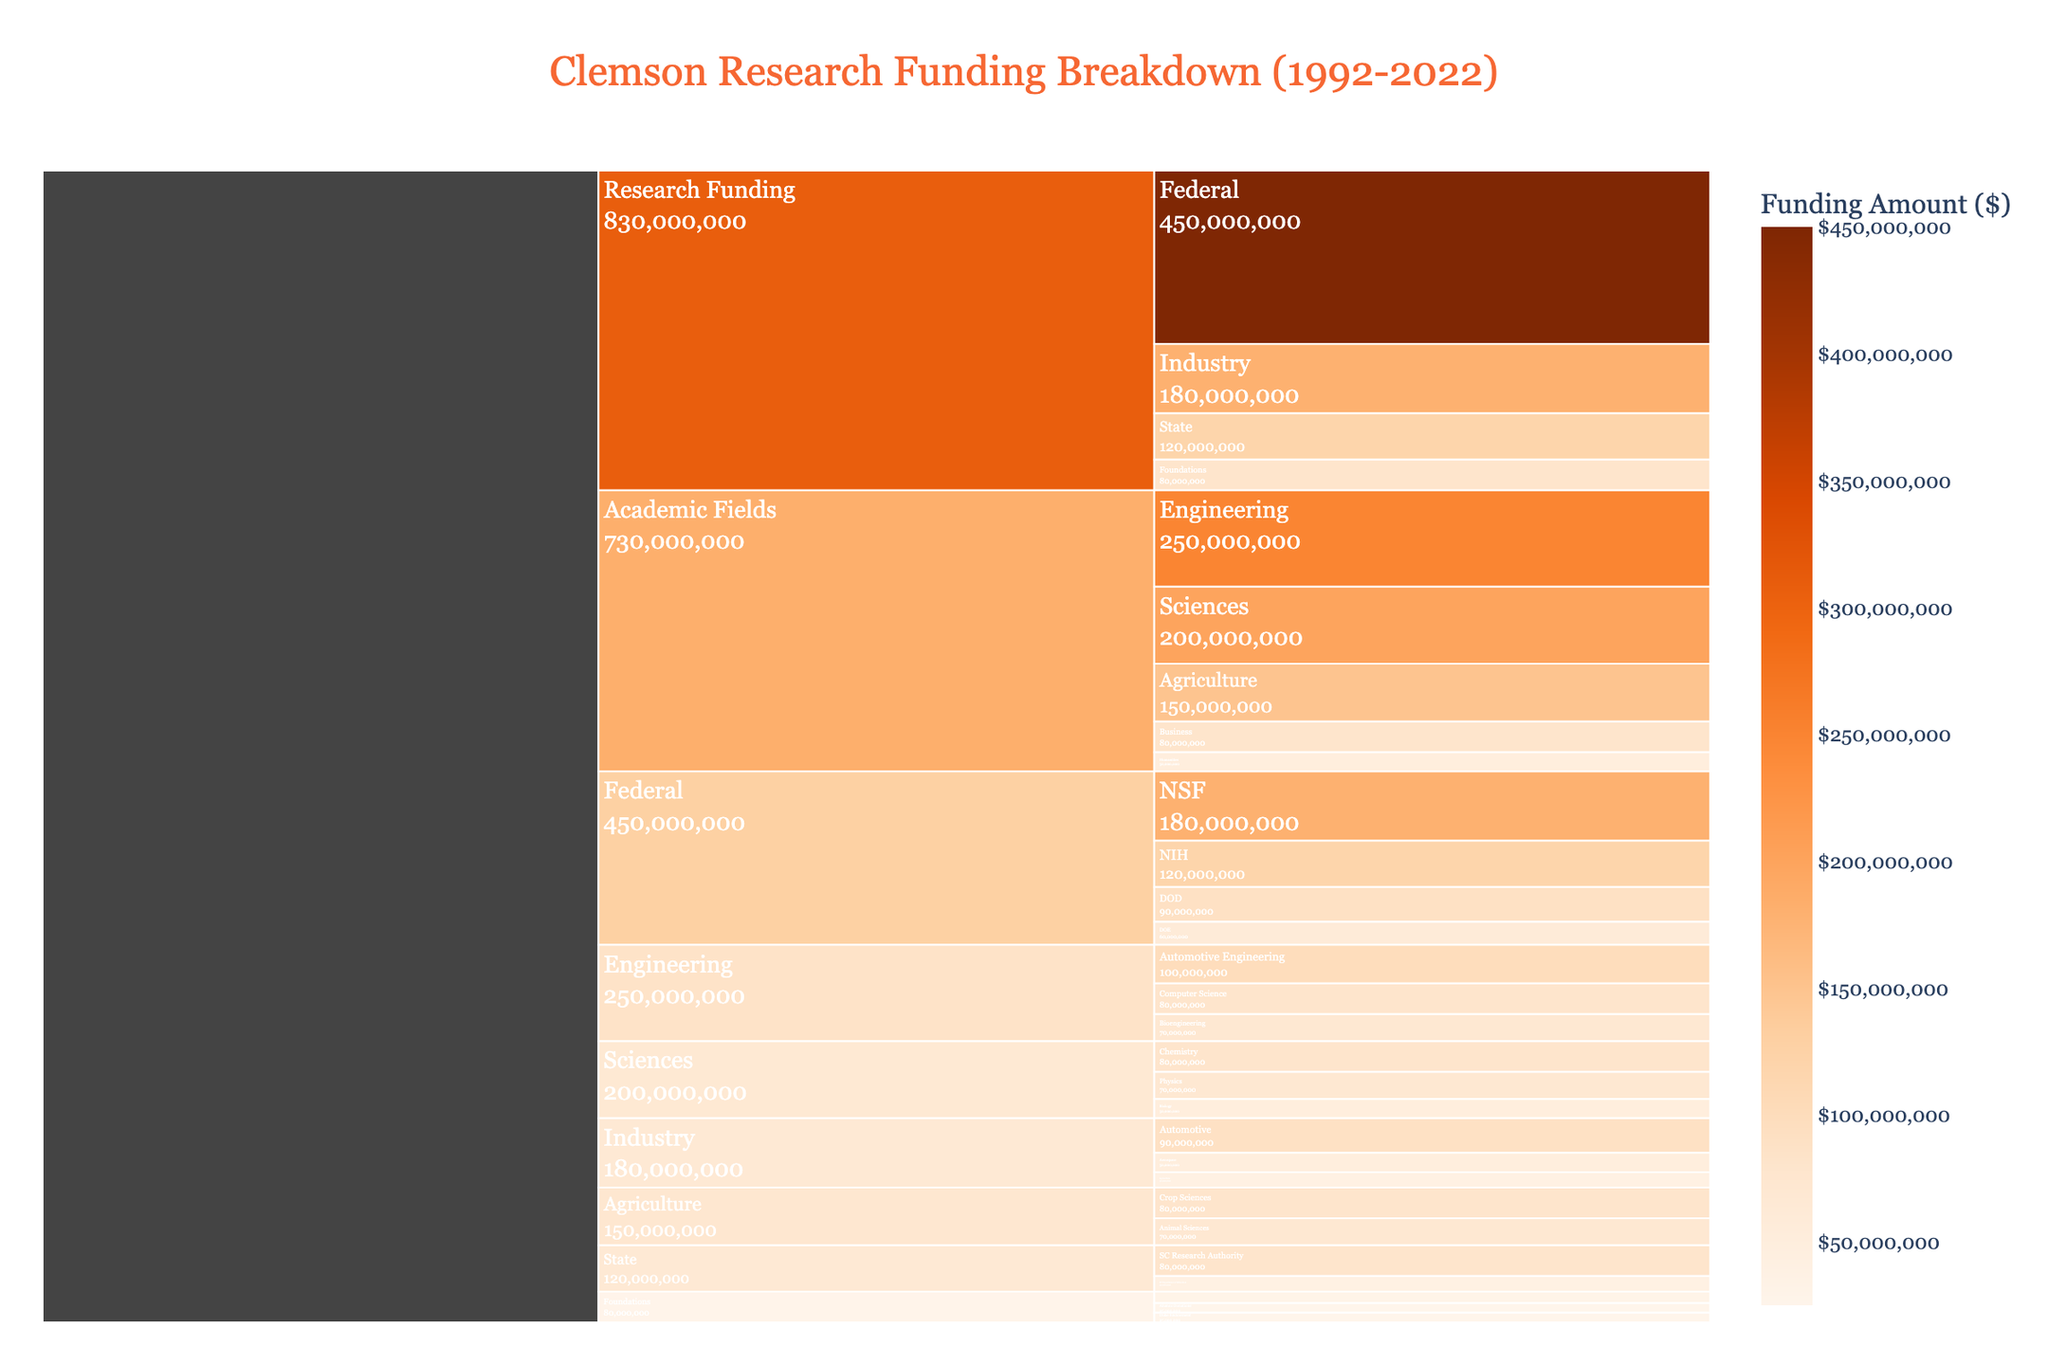What's the total amount of federal research funding for Clemson over the past 30 years? Add up the values of all subcategories under "Federal": NSF ($180,000,000), NIH ($120,000,000), DOD ($90,000,000), DOE ($60,000,000). Total = $180,000,000 + $120,000,000 + $90,000,000 + $60,000,000 = $450,000,000.
Answer: $450,000,000 What's the main source of research funding for Clemson? Look at the highest value among the main funding categories: Federal ($450,000,000), State ($120,000,000), Industry ($180,000,000), Foundations ($80,000,000).
Answer: Federal How much more funding does Engineering receive than Humanities? Subtract the value for Humanities from Engineering: $250,000,000 (Engineering) - $50,000,000 (Humanities) = $200,000,000.
Answer: $200,000,000 Which academic field gets the most research funding? Identify the category with the highest value under "Academic Fields": Engineering ($250,000,000), Sciences ($200,000,000), Agriculture ($150,000,000), Business ($80,000,000), Humanities ($50,000,000).
Answer: Engineering What's the total funding for academic fields related to Agriculture? Add the values of subcategories under "Agriculture": Crop Sciences ($80,000,000) + Animal Sciences ($70,000,000) = $150,000,000.
Answer: $150,000,000 How does the funding for Automotive compare between Industry and Engineering? Compare the values in the subcategories: Automotive in Industry ($90,000,000) to Automotive Engineering in Engineering ($100,000,000). Automotive Engineering in Engineering receives more funding compared to Automotive in Industry.
Answer: Automotive Engineering receives more What's the combined total research funding from Clemson's State and Foundation sources? Add the total State and Foundation values: $120,000,000 (State) + $80,000,000 (Foundations) = $200,000,000.
Answer: $200,000,000 Which funding source is larger: NSF or NIH? Compare their values: NSF ($180,000,000) versus NIH ($120,000,000).
Answer: NSF Between Bioengineering and Computer Science, which gets more funding? Compare the values directly: Bioengineering ($70,000,000) and Computer Science ($80,000,000).
Answer: Computer Science Among Federal subcategories, which receives the least funding? Identify the smallest value under "Federal": NSF ($180,000,000), NIH ($120,000,000), DOD ($90,000,000), DOE ($60,000,000).
Answer: DOE 